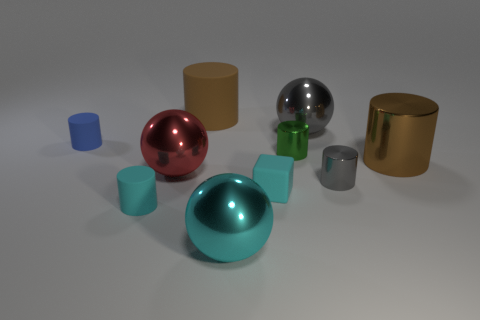Do the big rubber cylinder and the large shiny cylinder have the same color?
Give a very brief answer. Yes. There is a big metal object that is the same color as the block; what shape is it?
Make the answer very short. Sphere. What is the size of the metallic object that is the same color as the big matte object?
Provide a succinct answer. Large. There is a cyan rubber object that is left of the big matte thing; what is its size?
Offer a terse response. Small. Do the rubber cube and the brown cylinder left of the green cylinder have the same size?
Make the answer very short. No. What is the color of the shiny cylinder that is behind the thing to the right of the small gray cylinder?
Offer a terse response. Green. How many other things are the same color as the tiny block?
Keep it short and to the point. 2. The brown rubber cylinder has what size?
Keep it short and to the point. Large. Is the number of red things that are left of the red metal object greater than the number of cubes that are in front of the cyan sphere?
Ensure brevity in your answer.  No. There is a metallic cylinder behind the big metallic cylinder; what number of metal spheres are behind it?
Provide a short and direct response. 1. 